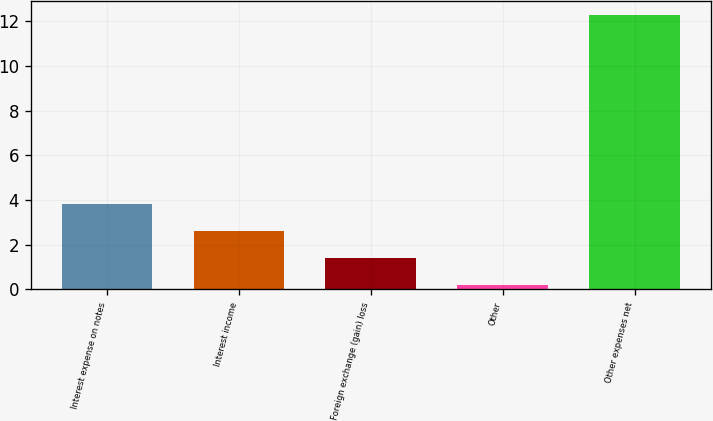<chart> <loc_0><loc_0><loc_500><loc_500><bar_chart><fcel>Interest expense on notes<fcel>Interest income<fcel>Foreign exchange (gain) loss<fcel>Other<fcel>Other expenses net<nl><fcel>3.83<fcel>2.62<fcel>1.41<fcel>0.2<fcel>12.3<nl></chart> 